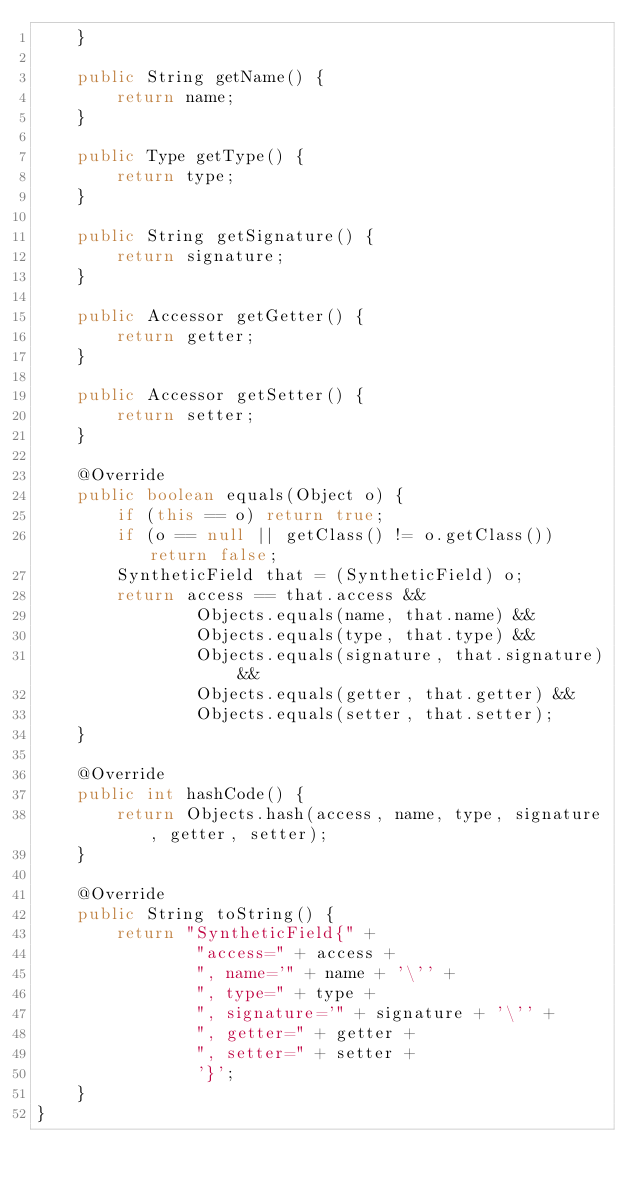Convert code to text. <code><loc_0><loc_0><loc_500><loc_500><_Java_>    }

    public String getName() {
        return name;
    }

    public Type getType() {
        return type;
    }

    public String getSignature() {
        return signature;
    }

    public Accessor getGetter() {
        return getter;
    }

    public Accessor getSetter() {
        return setter;
    }

    @Override
    public boolean equals(Object o) {
        if (this == o) return true;
        if (o == null || getClass() != o.getClass()) return false;
        SyntheticField that = (SyntheticField) o;
        return access == that.access &&
                Objects.equals(name, that.name) &&
                Objects.equals(type, that.type) &&
                Objects.equals(signature, that.signature) &&
                Objects.equals(getter, that.getter) &&
                Objects.equals(setter, that.setter);
    }

    @Override
    public int hashCode() {
        return Objects.hash(access, name, type, signature, getter, setter);
    }

    @Override
    public String toString() {
        return "SyntheticField{" +
                "access=" + access +
                ", name='" + name + '\'' +
                ", type=" + type +
                ", signature='" + signature + '\'' +
                ", getter=" + getter +
                ", setter=" + setter +
                '}';
    }
}
</code> 